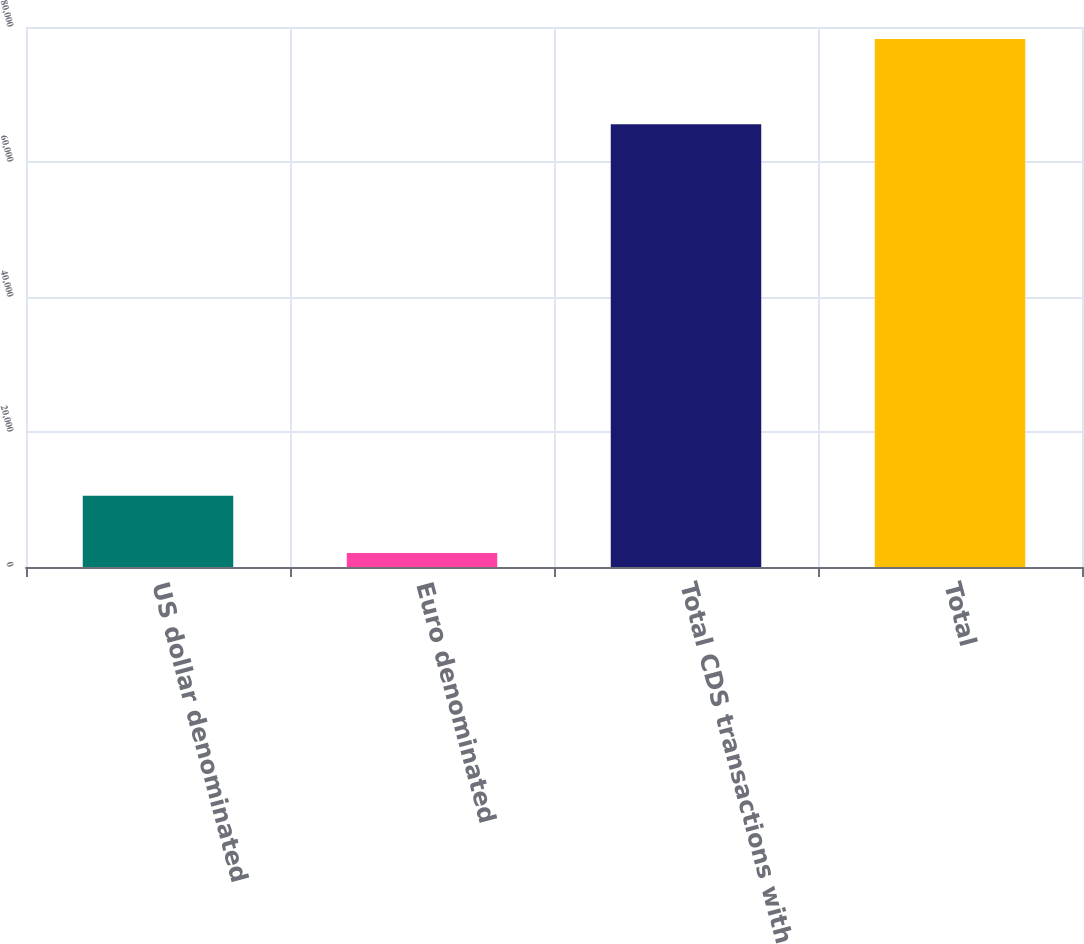Convert chart to OTSL. <chart><loc_0><loc_0><loc_500><loc_500><bar_chart><fcel>US dollar denominated<fcel>Euro denominated<fcel>Total CDS transactions with<fcel>Total<nl><fcel>10544<fcel>2075<fcel>65586<fcel>78205<nl></chart> 